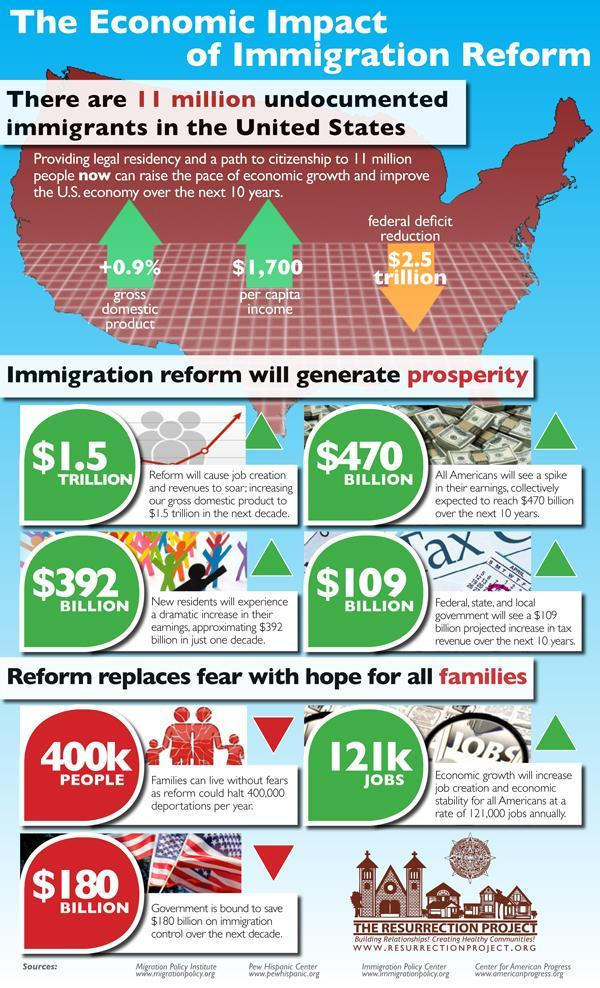What is the increase in earnings predicted in 10 years in dollars, 470 bn, 392 bn, or 109 mn?
Answer the question with a short phrase. 392 bn 